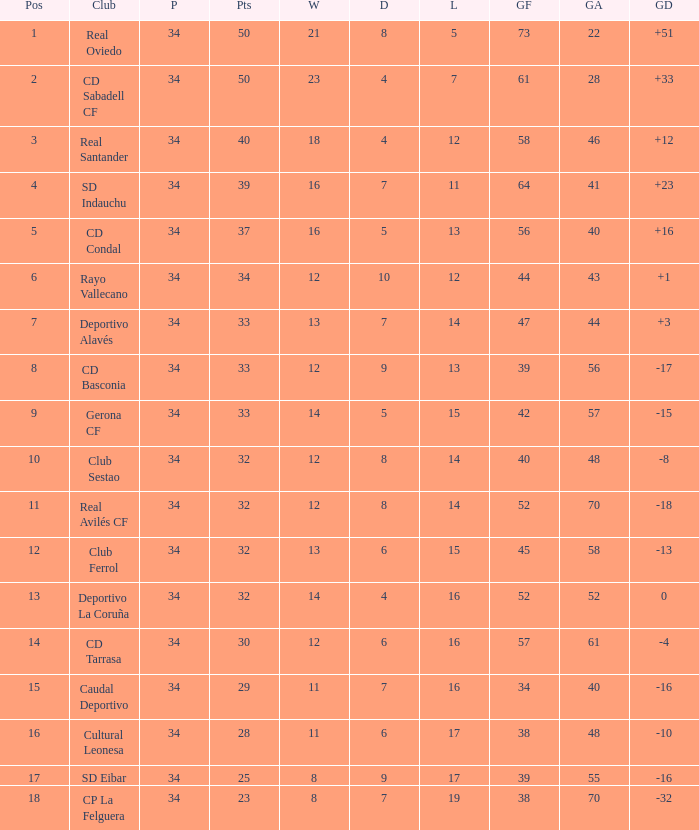Which Played has Draws smaller than 7, and Goals for smaller than 61, and Goals against smaller than 48, and a Position of 5? 34.0. 